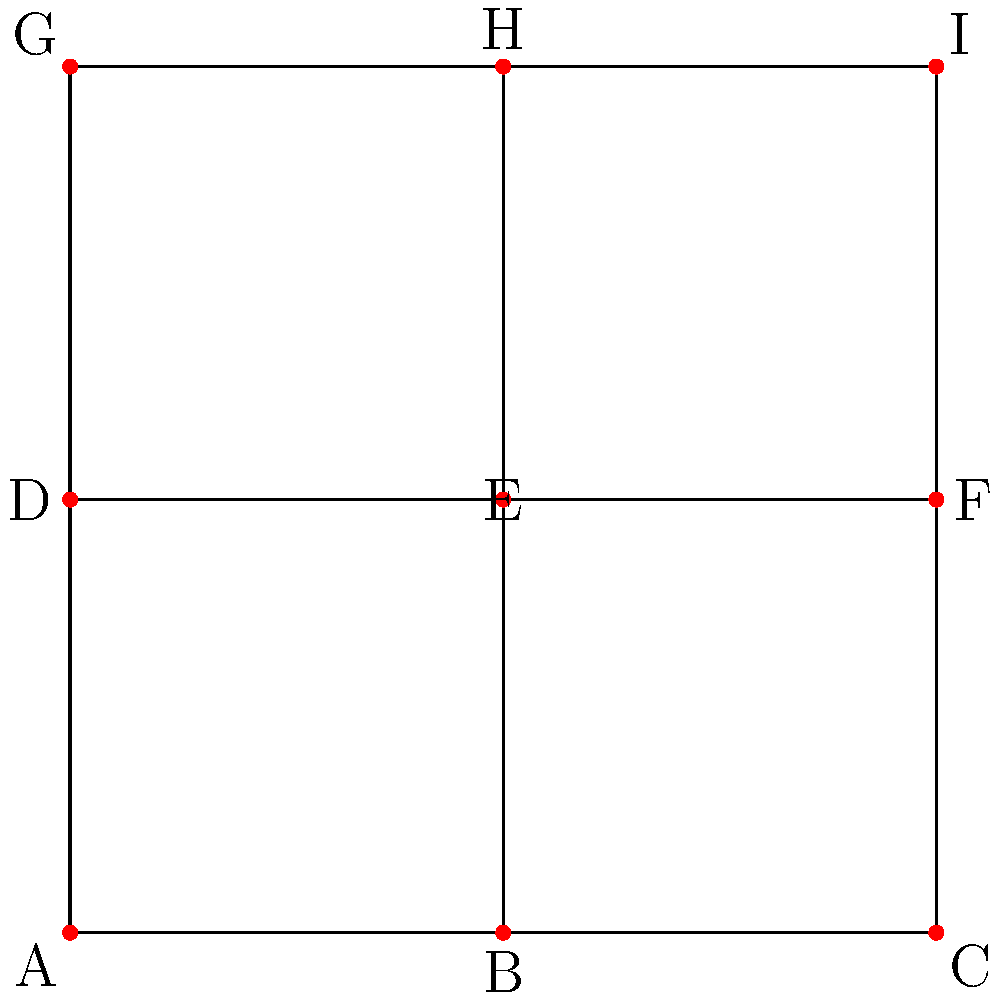The Cantu family's neighborhood is laid out in a 3x3 grid pattern, as shown in the diagram. Each intersection represents a potential location for a street light. What is the minimum number of street lights needed to ensure that every intersection is either illuminated or adjacent to an illuminated intersection? To solve this problem, we need to find the minimum dominating set of the graph. A dominating set is a subset of vertices such that every vertex not in the subset is adjacent to at least one vertex in the subset. The steps to find the solution are:

1. Observe that the graph is a 3x3 grid with 9 vertices (intersections).

2. Notice that the central intersection (E) is connected to four other intersections (B, D, F, H).

3. Placing a street light at E illuminates five intersections in total (including E itself).

4. To cover the remaining four corner intersections (A, C, G, I), we need at least two more street lights.

5. The optimal placement for these two additional lights would be at opposite corners, such as A and I.

6. With lights at A, E, and I, we ensure that:
   - A illuminates itself and B
   - E illuminates itself, B, D, F, and H
   - I illuminates itself and H

7. This configuration covers all 9 intersections with the minimum number of street lights.

Therefore, the minimum number of street lights needed is 3.
Answer: 3 street lights 